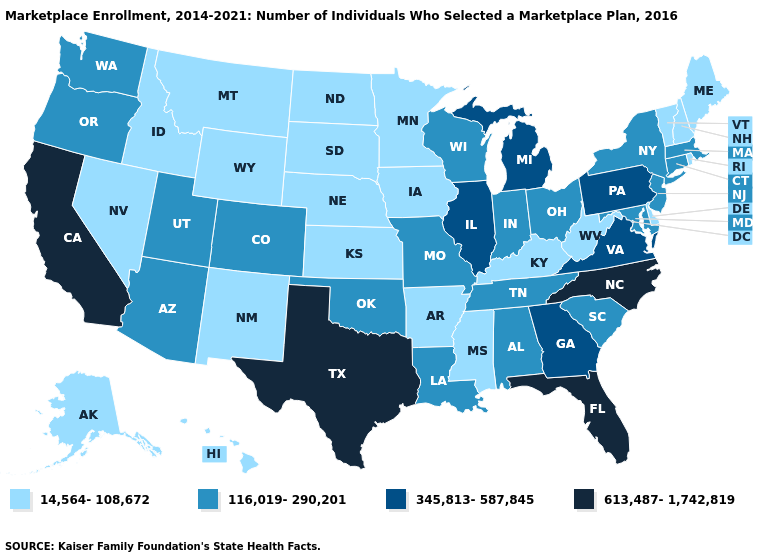What is the value of Oklahoma?
Keep it brief. 116,019-290,201. What is the value of Montana?
Write a very short answer. 14,564-108,672. What is the lowest value in states that border Indiana?
Quick response, please. 14,564-108,672. Does the first symbol in the legend represent the smallest category?
Concise answer only. Yes. What is the lowest value in the MidWest?
Keep it brief. 14,564-108,672. What is the highest value in the West ?
Give a very brief answer. 613,487-1,742,819. What is the highest value in the West ?
Answer briefly. 613,487-1,742,819. What is the value of Arizona?
Short answer required. 116,019-290,201. Does New Mexico have a higher value than Pennsylvania?
Keep it brief. No. What is the value of North Dakota?
Short answer required. 14,564-108,672. Name the states that have a value in the range 116,019-290,201?
Concise answer only. Alabama, Arizona, Colorado, Connecticut, Indiana, Louisiana, Maryland, Massachusetts, Missouri, New Jersey, New York, Ohio, Oklahoma, Oregon, South Carolina, Tennessee, Utah, Washington, Wisconsin. What is the value of Hawaii?
Concise answer only. 14,564-108,672. What is the value of Texas?
Answer briefly. 613,487-1,742,819. What is the highest value in states that border Virginia?
Give a very brief answer. 613,487-1,742,819. What is the value of Idaho?
Quick response, please. 14,564-108,672. 